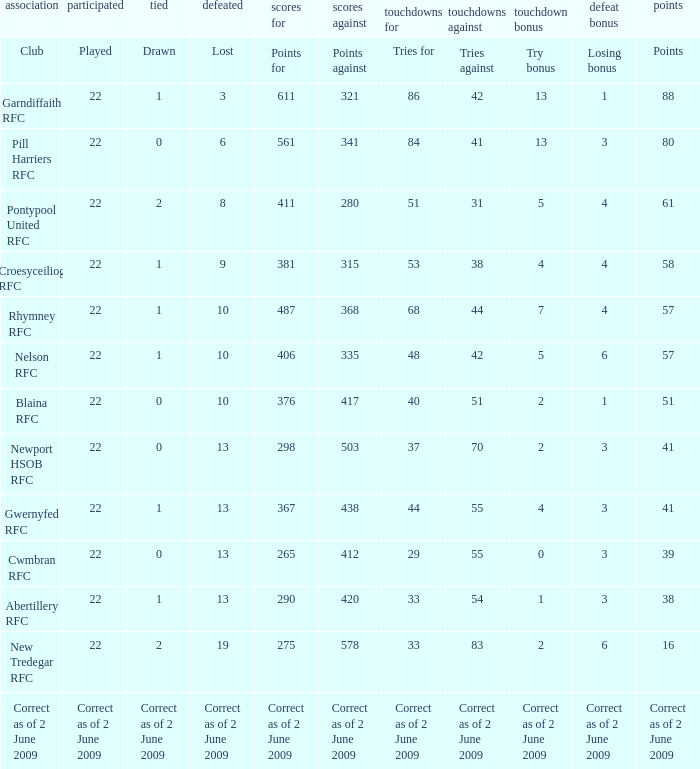Which club has 40 tries for? Blaina RFC. 